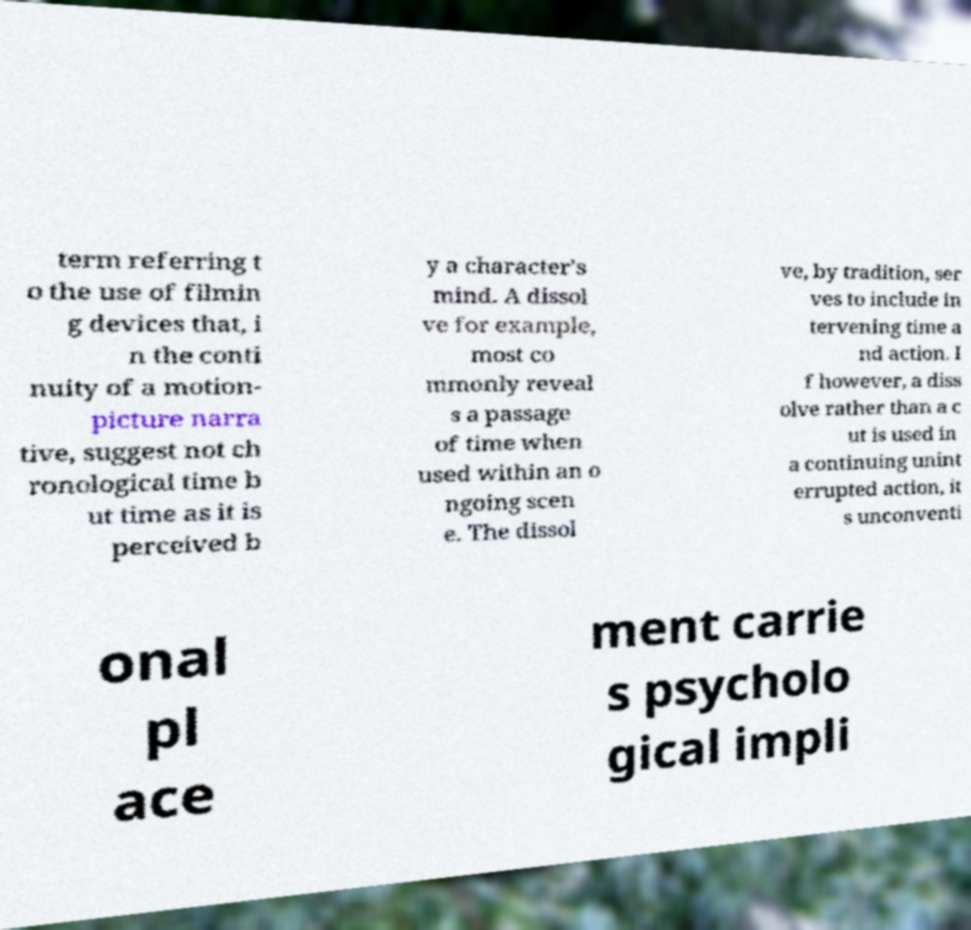Please identify and transcribe the text found in this image. term referring t o the use of filmin g devices that, i n the conti nuity of a motion- picture narra tive, suggest not ch ronological time b ut time as it is perceived b y a character's mind. A dissol ve for example, most co mmonly reveal s a passage of time when used within an o ngoing scen e. The dissol ve, by tradition, ser ves to include in tervening time a nd action. I f however, a diss olve rather than a c ut is used in a continuing unint errupted action, it s unconventi onal pl ace ment carrie s psycholo gical impli 